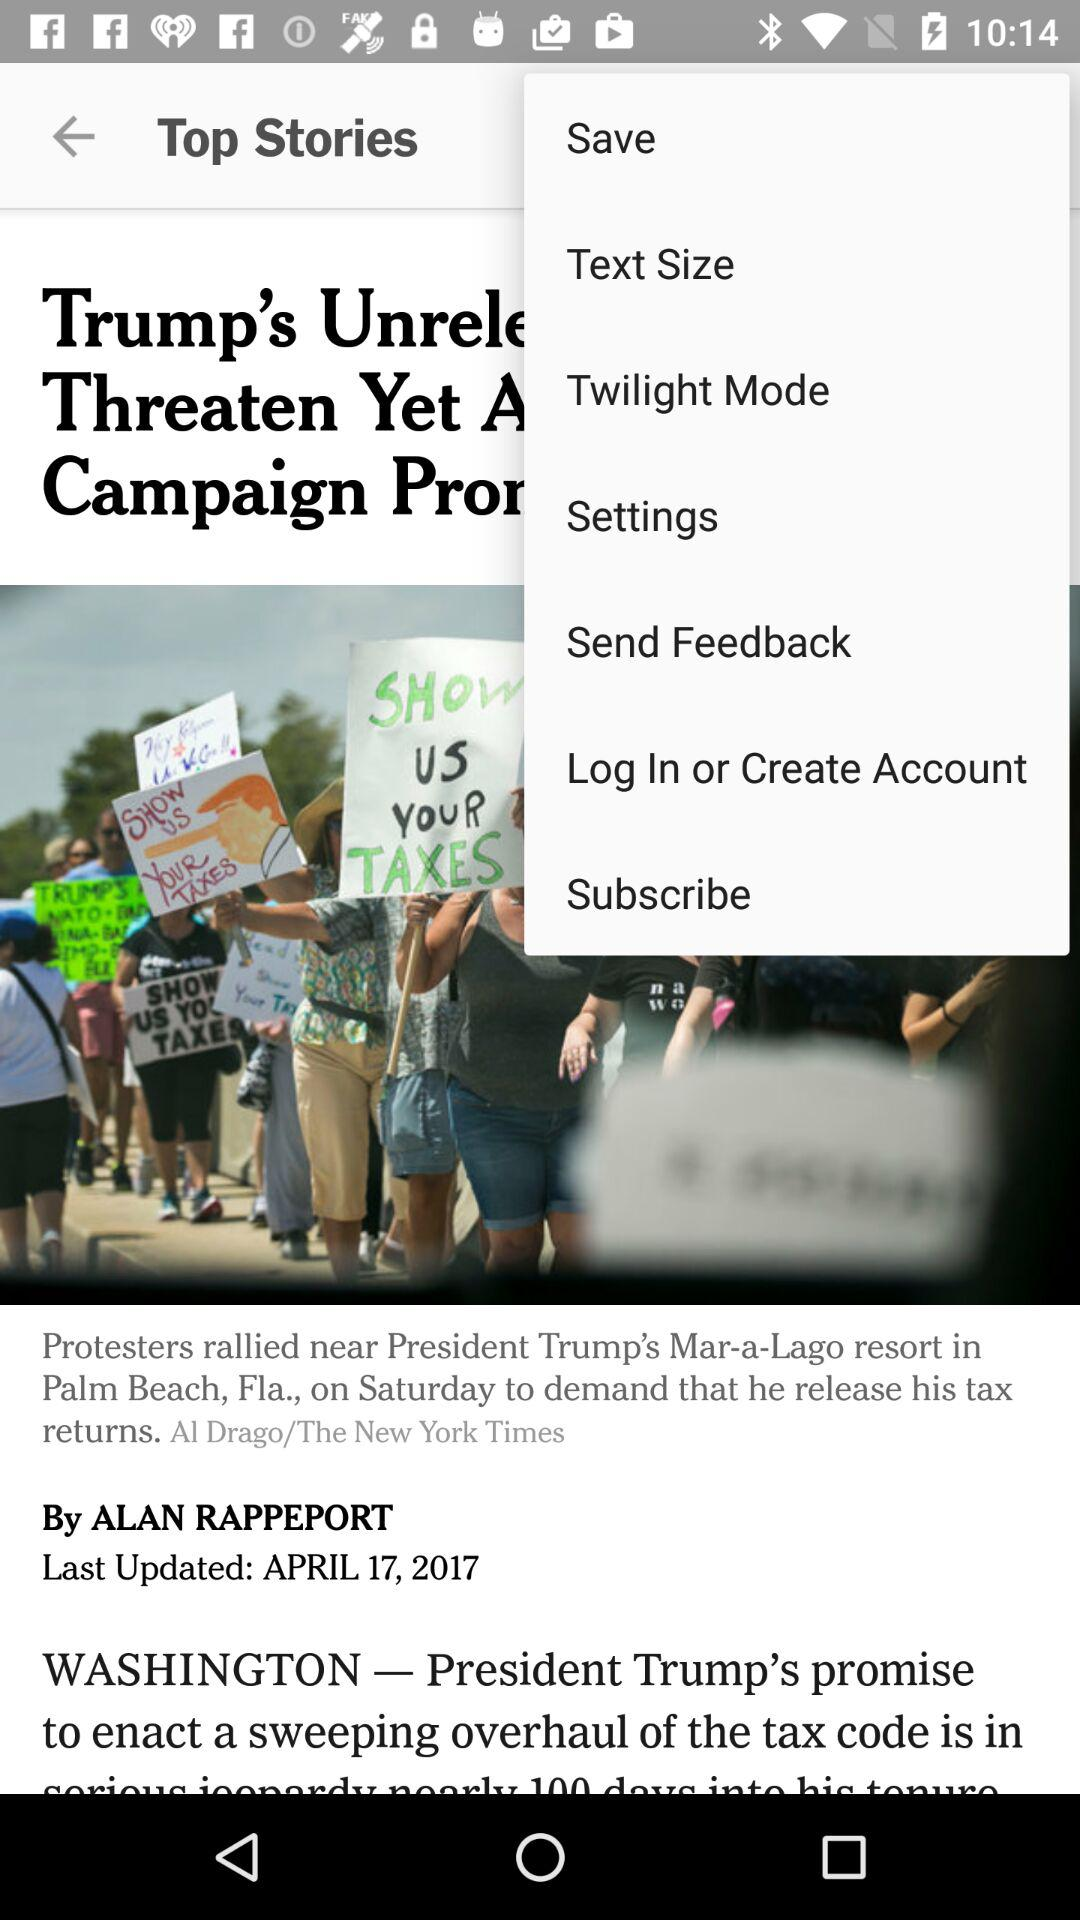What is the name of the article's author? The name of the author is Alan Rappeport. 